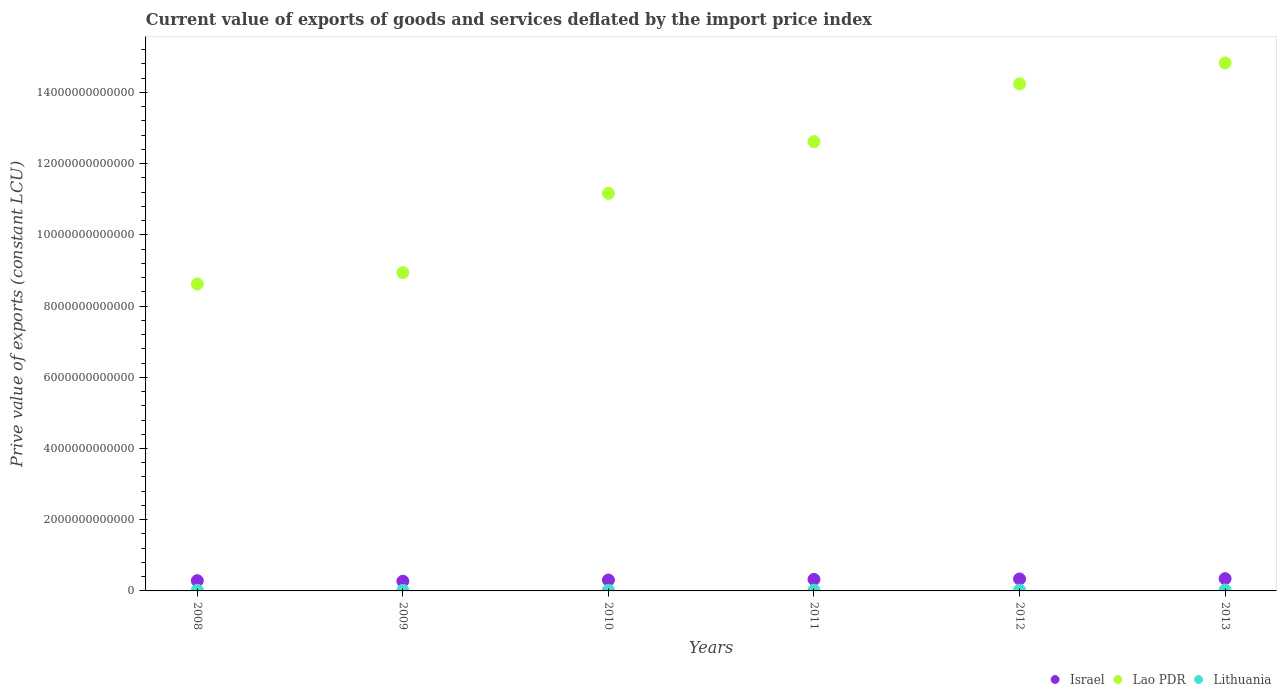How many different coloured dotlines are there?
Give a very brief answer. 3. What is the prive value of exports in Lithuania in 2013?
Provide a succinct answer. 2.54e+1. Across all years, what is the maximum prive value of exports in Israel?
Your answer should be compact. 3.45e+11. Across all years, what is the minimum prive value of exports in Israel?
Offer a very short reply. 2.74e+11. In which year was the prive value of exports in Israel minimum?
Your response must be concise. 2009. What is the total prive value of exports in Lithuania in the graph?
Offer a very short reply. 1.21e+11. What is the difference between the prive value of exports in Lao PDR in 2009 and that in 2012?
Give a very brief answer. -5.30e+12. What is the difference between the prive value of exports in Lithuania in 2011 and the prive value of exports in Lao PDR in 2009?
Ensure brevity in your answer.  -8.92e+12. What is the average prive value of exports in Lithuania per year?
Ensure brevity in your answer.  2.02e+1. In the year 2011, what is the difference between the prive value of exports in Lithuania and prive value of exports in Israel?
Keep it short and to the point. -3.02e+11. In how many years, is the prive value of exports in Lithuania greater than 10400000000000 LCU?
Your answer should be compact. 0. What is the ratio of the prive value of exports in Israel in 2008 to that in 2009?
Ensure brevity in your answer.  1.05. What is the difference between the highest and the second highest prive value of exports in Israel?
Your answer should be very brief. 8.65e+09. What is the difference between the highest and the lowest prive value of exports in Israel?
Keep it short and to the point. 7.11e+1. What is the difference between two consecutive major ticks on the Y-axis?
Offer a terse response. 2.00e+12. Are the values on the major ticks of Y-axis written in scientific E-notation?
Keep it short and to the point. No. Does the graph contain grids?
Ensure brevity in your answer.  No. How many legend labels are there?
Your response must be concise. 3. What is the title of the graph?
Offer a very short reply. Current value of exports of goods and services deflated by the import price index. Does "Guam" appear as one of the legend labels in the graph?
Make the answer very short. No. What is the label or title of the Y-axis?
Make the answer very short. Prive value of exports (constant LCU). What is the Prive value of exports (constant LCU) in Israel in 2008?
Give a very brief answer. 2.88e+11. What is the Prive value of exports (constant LCU) of Lao PDR in 2008?
Provide a short and direct response. 8.62e+12. What is the Prive value of exports (constant LCU) of Lithuania in 2008?
Keep it short and to the point. 1.83e+1. What is the Prive value of exports (constant LCU) in Israel in 2009?
Your answer should be very brief. 2.74e+11. What is the Prive value of exports (constant LCU) of Lao PDR in 2009?
Provide a short and direct response. 8.94e+12. What is the Prive value of exports (constant LCU) of Lithuania in 2009?
Offer a very short reply. 1.54e+1. What is the Prive value of exports (constant LCU) in Israel in 2010?
Your answer should be very brief. 3.07e+11. What is the Prive value of exports (constant LCU) in Lao PDR in 2010?
Your answer should be very brief. 1.12e+13. What is the Prive value of exports (constant LCU) in Lithuania in 2010?
Offer a very short reply. 1.83e+1. What is the Prive value of exports (constant LCU) in Israel in 2011?
Ensure brevity in your answer.  3.23e+11. What is the Prive value of exports (constant LCU) of Lao PDR in 2011?
Provide a short and direct response. 1.26e+13. What is the Prive value of exports (constant LCU) of Lithuania in 2011?
Give a very brief answer. 2.08e+1. What is the Prive value of exports (constant LCU) of Israel in 2012?
Your answer should be very brief. 3.36e+11. What is the Prive value of exports (constant LCU) in Lao PDR in 2012?
Make the answer very short. 1.42e+13. What is the Prive value of exports (constant LCU) in Lithuania in 2012?
Ensure brevity in your answer.  2.32e+1. What is the Prive value of exports (constant LCU) in Israel in 2013?
Your answer should be very brief. 3.45e+11. What is the Prive value of exports (constant LCU) of Lao PDR in 2013?
Your response must be concise. 1.48e+13. What is the Prive value of exports (constant LCU) of Lithuania in 2013?
Offer a very short reply. 2.54e+1. Across all years, what is the maximum Prive value of exports (constant LCU) in Israel?
Your response must be concise. 3.45e+11. Across all years, what is the maximum Prive value of exports (constant LCU) in Lao PDR?
Offer a very short reply. 1.48e+13. Across all years, what is the maximum Prive value of exports (constant LCU) of Lithuania?
Offer a terse response. 2.54e+1. Across all years, what is the minimum Prive value of exports (constant LCU) in Israel?
Ensure brevity in your answer.  2.74e+11. Across all years, what is the minimum Prive value of exports (constant LCU) in Lao PDR?
Your answer should be very brief. 8.62e+12. Across all years, what is the minimum Prive value of exports (constant LCU) of Lithuania?
Ensure brevity in your answer.  1.54e+1. What is the total Prive value of exports (constant LCU) of Israel in the graph?
Your answer should be very brief. 1.87e+12. What is the total Prive value of exports (constant LCU) of Lao PDR in the graph?
Give a very brief answer. 7.04e+13. What is the total Prive value of exports (constant LCU) in Lithuania in the graph?
Provide a succinct answer. 1.21e+11. What is the difference between the Prive value of exports (constant LCU) of Israel in 2008 and that in 2009?
Provide a short and direct response. 1.40e+1. What is the difference between the Prive value of exports (constant LCU) of Lao PDR in 2008 and that in 2009?
Make the answer very short. -3.18e+11. What is the difference between the Prive value of exports (constant LCU) of Lithuania in 2008 and that in 2009?
Your answer should be compact. 2.96e+09. What is the difference between the Prive value of exports (constant LCU) of Israel in 2008 and that in 2010?
Make the answer very short. -1.92e+1. What is the difference between the Prive value of exports (constant LCU) in Lao PDR in 2008 and that in 2010?
Offer a terse response. -2.54e+12. What is the difference between the Prive value of exports (constant LCU) in Lithuania in 2008 and that in 2010?
Give a very brief answer. 2.17e+07. What is the difference between the Prive value of exports (constant LCU) in Israel in 2008 and that in 2011?
Provide a succinct answer. -3.54e+1. What is the difference between the Prive value of exports (constant LCU) in Lao PDR in 2008 and that in 2011?
Keep it short and to the point. -4.00e+12. What is the difference between the Prive value of exports (constant LCU) in Lithuania in 2008 and that in 2011?
Offer a terse response. -2.47e+09. What is the difference between the Prive value of exports (constant LCU) in Israel in 2008 and that in 2012?
Offer a very short reply. -4.84e+1. What is the difference between the Prive value of exports (constant LCU) in Lao PDR in 2008 and that in 2012?
Your answer should be compact. -5.62e+12. What is the difference between the Prive value of exports (constant LCU) in Lithuania in 2008 and that in 2012?
Ensure brevity in your answer.  -4.84e+09. What is the difference between the Prive value of exports (constant LCU) of Israel in 2008 and that in 2013?
Keep it short and to the point. -5.71e+1. What is the difference between the Prive value of exports (constant LCU) of Lao PDR in 2008 and that in 2013?
Your response must be concise. -6.21e+12. What is the difference between the Prive value of exports (constant LCU) of Lithuania in 2008 and that in 2013?
Offer a very short reply. -7.11e+09. What is the difference between the Prive value of exports (constant LCU) of Israel in 2009 and that in 2010?
Provide a short and direct response. -3.32e+1. What is the difference between the Prive value of exports (constant LCU) in Lao PDR in 2009 and that in 2010?
Your response must be concise. -2.23e+12. What is the difference between the Prive value of exports (constant LCU) of Lithuania in 2009 and that in 2010?
Offer a very short reply. -2.94e+09. What is the difference between the Prive value of exports (constant LCU) of Israel in 2009 and that in 2011?
Provide a short and direct response. -4.94e+1. What is the difference between the Prive value of exports (constant LCU) of Lao PDR in 2009 and that in 2011?
Provide a succinct answer. -3.68e+12. What is the difference between the Prive value of exports (constant LCU) of Lithuania in 2009 and that in 2011?
Offer a terse response. -5.42e+09. What is the difference between the Prive value of exports (constant LCU) of Israel in 2009 and that in 2012?
Your answer should be compact. -6.25e+1. What is the difference between the Prive value of exports (constant LCU) in Lao PDR in 2009 and that in 2012?
Your response must be concise. -5.30e+12. What is the difference between the Prive value of exports (constant LCU) of Lithuania in 2009 and that in 2012?
Ensure brevity in your answer.  -7.79e+09. What is the difference between the Prive value of exports (constant LCU) of Israel in 2009 and that in 2013?
Keep it short and to the point. -7.11e+1. What is the difference between the Prive value of exports (constant LCU) of Lao PDR in 2009 and that in 2013?
Offer a very short reply. -5.89e+12. What is the difference between the Prive value of exports (constant LCU) in Lithuania in 2009 and that in 2013?
Provide a short and direct response. -1.01e+1. What is the difference between the Prive value of exports (constant LCU) in Israel in 2010 and that in 2011?
Provide a succinct answer. -1.62e+1. What is the difference between the Prive value of exports (constant LCU) of Lao PDR in 2010 and that in 2011?
Keep it short and to the point. -1.45e+12. What is the difference between the Prive value of exports (constant LCU) of Lithuania in 2010 and that in 2011?
Provide a succinct answer. -2.49e+09. What is the difference between the Prive value of exports (constant LCU) in Israel in 2010 and that in 2012?
Keep it short and to the point. -2.93e+1. What is the difference between the Prive value of exports (constant LCU) in Lao PDR in 2010 and that in 2012?
Your answer should be compact. -3.08e+12. What is the difference between the Prive value of exports (constant LCU) of Lithuania in 2010 and that in 2012?
Give a very brief answer. -4.86e+09. What is the difference between the Prive value of exports (constant LCU) in Israel in 2010 and that in 2013?
Your answer should be very brief. -3.79e+1. What is the difference between the Prive value of exports (constant LCU) in Lao PDR in 2010 and that in 2013?
Provide a succinct answer. -3.66e+12. What is the difference between the Prive value of exports (constant LCU) in Lithuania in 2010 and that in 2013?
Offer a terse response. -7.13e+09. What is the difference between the Prive value of exports (constant LCU) of Israel in 2011 and that in 2012?
Ensure brevity in your answer.  -1.30e+1. What is the difference between the Prive value of exports (constant LCU) in Lao PDR in 2011 and that in 2012?
Make the answer very short. -1.62e+12. What is the difference between the Prive value of exports (constant LCU) of Lithuania in 2011 and that in 2012?
Keep it short and to the point. -2.37e+09. What is the difference between the Prive value of exports (constant LCU) of Israel in 2011 and that in 2013?
Give a very brief answer. -2.17e+1. What is the difference between the Prive value of exports (constant LCU) in Lao PDR in 2011 and that in 2013?
Offer a terse response. -2.21e+12. What is the difference between the Prive value of exports (constant LCU) in Lithuania in 2011 and that in 2013?
Your response must be concise. -4.64e+09. What is the difference between the Prive value of exports (constant LCU) of Israel in 2012 and that in 2013?
Provide a short and direct response. -8.65e+09. What is the difference between the Prive value of exports (constant LCU) in Lao PDR in 2012 and that in 2013?
Provide a short and direct response. -5.88e+11. What is the difference between the Prive value of exports (constant LCU) of Lithuania in 2012 and that in 2013?
Your answer should be very brief. -2.27e+09. What is the difference between the Prive value of exports (constant LCU) of Israel in 2008 and the Prive value of exports (constant LCU) of Lao PDR in 2009?
Ensure brevity in your answer.  -8.65e+12. What is the difference between the Prive value of exports (constant LCU) in Israel in 2008 and the Prive value of exports (constant LCU) in Lithuania in 2009?
Your response must be concise. 2.72e+11. What is the difference between the Prive value of exports (constant LCU) in Lao PDR in 2008 and the Prive value of exports (constant LCU) in Lithuania in 2009?
Offer a very short reply. 8.60e+12. What is the difference between the Prive value of exports (constant LCU) in Israel in 2008 and the Prive value of exports (constant LCU) in Lao PDR in 2010?
Give a very brief answer. -1.09e+13. What is the difference between the Prive value of exports (constant LCU) in Israel in 2008 and the Prive value of exports (constant LCU) in Lithuania in 2010?
Your response must be concise. 2.69e+11. What is the difference between the Prive value of exports (constant LCU) in Lao PDR in 2008 and the Prive value of exports (constant LCU) in Lithuania in 2010?
Your answer should be very brief. 8.60e+12. What is the difference between the Prive value of exports (constant LCU) of Israel in 2008 and the Prive value of exports (constant LCU) of Lao PDR in 2011?
Offer a very short reply. -1.23e+13. What is the difference between the Prive value of exports (constant LCU) of Israel in 2008 and the Prive value of exports (constant LCU) of Lithuania in 2011?
Your answer should be compact. 2.67e+11. What is the difference between the Prive value of exports (constant LCU) in Lao PDR in 2008 and the Prive value of exports (constant LCU) in Lithuania in 2011?
Offer a very short reply. 8.60e+12. What is the difference between the Prive value of exports (constant LCU) in Israel in 2008 and the Prive value of exports (constant LCU) in Lao PDR in 2012?
Provide a succinct answer. -1.40e+13. What is the difference between the Prive value of exports (constant LCU) in Israel in 2008 and the Prive value of exports (constant LCU) in Lithuania in 2012?
Make the answer very short. 2.64e+11. What is the difference between the Prive value of exports (constant LCU) in Lao PDR in 2008 and the Prive value of exports (constant LCU) in Lithuania in 2012?
Give a very brief answer. 8.60e+12. What is the difference between the Prive value of exports (constant LCU) in Israel in 2008 and the Prive value of exports (constant LCU) in Lao PDR in 2013?
Your answer should be compact. -1.45e+13. What is the difference between the Prive value of exports (constant LCU) in Israel in 2008 and the Prive value of exports (constant LCU) in Lithuania in 2013?
Make the answer very short. 2.62e+11. What is the difference between the Prive value of exports (constant LCU) of Lao PDR in 2008 and the Prive value of exports (constant LCU) of Lithuania in 2013?
Your answer should be compact. 8.59e+12. What is the difference between the Prive value of exports (constant LCU) in Israel in 2009 and the Prive value of exports (constant LCU) in Lao PDR in 2010?
Keep it short and to the point. -1.09e+13. What is the difference between the Prive value of exports (constant LCU) in Israel in 2009 and the Prive value of exports (constant LCU) in Lithuania in 2010?
Provide a short and direct response. 2.55e+11. What is the difference between the Prive value of exports (constant LCU) in Lao PDR in 2009 and the Prive value of exports (constant LCU) in Lithuania in 2010?
Provide a succinct answer. 8.92e+12. What is the difference between the Prive value of exports (constant LCU) in Israel in 2009 and the Prive value of exports (constant LCU) in Lao PDR in 2011?
Your answer should be very brief. -1.23e+13. What is the difference between the Prive value of exports (constant LCU) in Israel in 2009 and the Prive value of exports (constant LCU) in Lithuania in 2011?
Your answer should be compact. 2.53e+11. What is the difference between the Prive value of exports (constant LCU) in Lao PDR in 2009 and the Prive value of exports (constant LCU) in Lithuania in 2011?
Keep it short and to the point. 8.92e+12. What is the difference between the Prive value of exports (constant LCU) of Israel in 2009 and the Prive value of exports (constant LCU) of Lao PDR in 2012?
Offer a terse response. -1.40e+13. What is the difference between the Prive value of exports (constant LCU) of Israel in 2009 and the Prive value of exports (constant LCU) of Lithuania in 2012?
Provide a succinct answer. 2.50e+11. What is the difference between the Prive value of exports (constant LCU) in Lao PDR in 2009 and the Prive value of exports (constant LCU) in Lithuania in 2012?
Offer a very short reply. 8.91e+12. What is the difference between the Prive value of exports (constant LCU) in Israel in 2009 and the Prive value of exports (constant LCU) in Lao PDR in 2013?
Provide a short and direct response. -1.46e+13. What is the difference between the Prive value of exports (constant LCU) of Israel in 2009 and the Prive value of exports (constant LCU) of Lithuania in 2013?
Offer a terse response. 2.48e+11. What is the difference between the Prive value of exports (constant LCU) of Lao PDR in 2009 and the Prive value of exports (constant LCU) of Lithuania in 2013?
Your answer should be very brief. 8.91e+12. What is the difference between the Prive value of exports (constant LCU) of Israel in 2010 and the Prive value of exports (constant LCU) of Lao PDR in 2011?
Provide a short and direct response. -1.23e+13. What is the difference between the Prive value of exports (constant LCU) of Israel in 2010 and the Prive value of exports (constant LCU) of Lithuania in 2011?
Your response must be concise. 2.86e+11. What is the difference between the Prive value of exports (constant LCU) of Lao PDR in 2010 and the Prive value of exports (constant LCU) of Lithuania in 2011?
Provide a succinct answer. 1.11e+13. What is the difference between the Prive value of exports (constant LCU) of Israel in 2010 and the Prive value of exports (constant LCU) of Lao PDR in 2012?
Your answer should be compact. -1.39e+13. What is the difference between the Prive value of exports (constant LCU) of Israel in 2010 and the Prive value of exports (constant LCU) of Lithuania in 2012?
Offer a terse response. 2.84e+11. What is the difference between the Prive value of exports (constant LCU) in Lao PDR in 2010 and the Prive value of exports (constant LCU) in Lithuania in 2012?
Make the answer very short. 1.11e+13. What is the difference between the Prive value of exports (constant LCU) in Israel in 2010 and the Prive value of exports (constant LCU) in Lao PDR in 2013?
Offer a very short reply. -1.45e+13. What is the difference between the Prive value of exports (constant LCU) in Israel in 2010 and the Prive value of exports (constant LCU) in Lithuania in 2013?
Make the answer very short. 2.81e+11. What is the difference between the Prive value of exports (constant LCU) in Lao PDR in 2010 and the Prive value of exports (constant LCU) in Lithuania in 2013?
Your response must be concise. 1.11e+13. What is the difference between the Prive value of exports (constant LCU) of Israel in 2011 and the Prive value of exports (constant LCU) of Lao PDR in 2012?
Provide a succinct answer. -1.39e+13. What is the difference between the Prive value of exports (constant LCU) in Israel in 2011 and the Prive value of exports (constant LCU) in Lithuania in 2012?
Give a very brief answer. 3.00e+11. What is the difference between the Prive value of exports (constant LCU) of Lao PDR in 2011 and the Prive value of exports (constant LCU) of Lithuania in 2012?
Provide a succinct answer. 1.26e+13. What is the difference between the Prive value of exports (constant LCU) of Israel in 2011 and the Prive value of exports (constant LCU) of Lao PDR in 2013?
Offer a terse response. -1.45e+13. What is the difference between the Prive value of exports (constant LCU) in Israel in 2011 and the Prive value of exports (constant LCU) in Lithuania in 2013?
Your answer should be very brief. 2.98e+11. What is the difference between the Prive value of exports (constant LCU) in Lao PDR in 2011 and the Prive value of exports (constant LCU) in Lithuania in 2013?
Your answer should be compact. 1.26e+13. What is the difference between the Prive value of exports (constant LCU) in Israel in 2012 and the Prive value of exports (constant LCU) in Lao PDR in 2013?
Provide a succinct answer. -1.45e+13. What is the difference between the Prive value of exports (constant LCU) of Israel in 2012 and the Prive value of exports (constant LCU) of Lithuania in 2013?
Ensure brevity in your answer.  3.11e+11. What is the difference between the Prive value of exports (constant LCU) of Lao PDR in 2012 and the Prive value of exports (constant LCU) of Lithuania in 2013?
Give a very brief answer. 1.42e+13. What is the average Prive value of exports (constant LCU) of Israel per year?
Provide a short and direct response. 3.12e+11. What is the average Prive value of exports (constant LCU) in Lao PDR per year?
Make the answer very short. 1.17e+13. What is the average Prive value of exports (constant LCU) of Lithuania per year?
Provide a short and direct response. 2.02e+1. In the year 2008, what is the difference between the Prive value of exports (constant LCU) in Israel and Prive value of exports (constant LCU) in Lao PDR?
Your response must be concise. -8.33e+12. In the year 2008, what is the difference between the Prive value of exports (constant LCU) of Israel and Prive value of exports (constant LCU) of Lithuania?
Make the answer very short. 2.69e+11. In the year 2008, what is the difference between the Prive value of exports (constant LCU) in Lao PDR and Prive value of exports (constant LCU) in Lithuania?
Keep it short and to the point. 8.60e+12. In the year 2009, what is the difference between the Prive value of exports (constant LCU) of Israel and Prive value of exports (constant LCU) of Lao PDR?
Offer a terse response. -8.66e+12. In the year 2009, what is the difference between the Prive value of exports (constant LCU) in Israel and Prive value of exports (constant LCU) in Lithuania?
Offer a very short reply. 2.58e+11. In the year 2009, what is the difference between the Prive value of exports (constant LCU) of Lao PDR and Prive value of exports (constant LCU) of Lithuania?
Give a very brief answer. 8.92e+12. In the year 2010, what is the difference between the Prive value of exports (constant LCU) in Israel and Prive value of exports (constant LCU) in Lao PDR?
Provide a succinct answer. -1.09e+13. In the year 2010, what is the difference between the Prive value of exports (constant LCU) of Israel and Prive value of exports (constant LCU) of Lithuania?
Your answer should be very brief. 2.88e+11. In the year 2010, what is the difference between the Prive value of exports (constant LCU) of Lao PDR and Prive value of exports (constant LCU) of Lithuania?
Your response must be concise. 1.11e+13. In the year 2011, what is the difference between the Prive value of exports (constant LCU) of Israel and Prive value of exports (constant LCU) of Lao PDR?
Your answer should be compact. -1.23e+13. In the year 2011, what is the difference between the Prive value of exports (constant LCU) in Israel and Prive value of exports (constant LCU) in Lithuania?
Your answer should be compact. 3.02e+11. In the year 2011, what is the difference between the Prive value of exports (constant LCU) in Lao PDR and Prive value of exports (constant LCU) in Lithuania?
Make the answer very short. 1.26e+13. In the year 2012, what is the difference between the Prive value of exports (constant LCU) in Israel and Prive value of exports (constant LCU) in Lao PDR?
Ensure brevity in your answer.  -1.39e+13. In the year 2012, what is the difference between the Prive value of exports (constant LCU) in Israel and Prive value of exports (constant LCU) in Lithuania?
Make the answer very short. 3.13e+11. In the year 2012, what is the difference between the Prive value of exports (constant LCU) of Lao PDR and Prive value of exports (constant LCU) of Lithuania?
Ensure brevity in your answer.  1.42e+13. In the year 2013, what is the difference between the Prive value of exports (constant LCU) in Israel and Prive value of exports (constant LCU) in Lao PDR?
Offer a terse response. -1.45e+13. In the year 2013, what is the difference between the Prive value of exports (constant LCU) of Israel and Prive value of exports (constant LCU) of Lithuania?
Your answer should be very brief. 3.19e+11. In the year 2013, what is the difference between the Prive value of exports (constant LCU) in Lao PDR and Prive value of exports (constant LCU) in Lithuania?
Your response must be concise. 1.48e+13. What is the ratio of the Prive value of exports (constant LCU) in Israel in 2008 to that in 2009?
Your response must be concise. 1.05. What is the ratio of the Prive value of exports (constant LCU) of Lao PDR in 2008 to that in 2009?
Offer a terse response. 0.96. What is the ratio of the Prive value of exports (constant LCU) in Lithuania in 2008 to that in 2009?
Provide a short and direct response. 1.19. What is the ratio of the Prive value of exports (constant LCU) in Israel in 2008 to that in 2010?
Make the answer very short. 0.94. What is the ratio of the Prive value of exports (constant LCU) in Lao PDR in 2008 to that in 2010?
Provide a short and direct response. 0.77. What is the ratio of the Prive value of exports (constant LCU) in Israel in 2008 to that in 2011?
Your answer should be compact. 0.89. What is the ratio of the Prive value of exports (constant LCU) of Lao PDR in 2008 to that in 2011?
Give a very brief answer. 0.68. What is the ratio of the Prive value of exports (constant LCU) of Lithuania in 2008 to that in 2011?
Provide a succinct answer. 0.88. What is the ratio of the Prive value of exports (constant LCU) in Israel in 2008 to that in 2012?
Give a very brief answer. 0.86. What is the ratio of the Prive value of exports (constant LCU) in Lao PDR in 2008 to that in 2012?
Your response must be concise. 0.61. What is the ratio of the Prive value of exports (constant LCU) in Lithuania in 2008 to that in 2012?
Your answer should be very brief. 0.79. What is the ratio of the Prive value of exports (constant LCU) in Israel in 2008 to that in 2013?
Give a very brief answer. 0.83. What is the ratio of the Prive value of exports (constant LCU) of Lao PDR in 2008 to that in 2013?
Provide a succinct answer. 0.58. What is the ratio of the Prive value of exports (constant LCU) of Lithuania in 2008 to that in 2013?
Offer a terse response. 0.72. What is the ratio of the Prive value of exports (constant LCU) of Israel in 2009 to that in 2010?
Provide a succinct answer. 0.89. What is the ratio of the Prive value of exports (constant LCU) of Lao PDR in 2009 to that in 2010?
Ensure brevity in your answer.  0.8. What is the ratio of the Prive value of exports (constant LCU) in Lithuania in 2009 to that in 2010?
Offer a terse response. 0.84. What is the ratio of the Prive value of exports (constant LCU) of Israel in 2009 to that in 2011?
Your answer should be compact. 0.85. What is the ratio of the Prive value of exports (constant LCU) of Lao PDR in 2009 to that in 2011?
Your answer should be compact. 0.71. What is the ratio of the Prive value of exports (constant LCU) in Lithuania in 2009 to that in 2011?
Provide a succinct answer. 0.74. What is the ratio of the Prive value of exports (constant LCU) in Israel in 2009 to that in 2012?
Ensure brevity in your answer.  0.81. What is the ratio of the Prive value of exports (constant LCU) of Lao PDR in 2009 to that in 2012?
Keep it short and to the point. 0.63. What is the ratio of the Prive value of exports (constant LCU) of Lithuania in 2009 to that in 2012?
Ensure brevity in your answer.  0.66. What is the ratio of the Prive value of exports (constant LCU) of Israel in 2009 to that in 2013?
Offer a very short reply. 0.79. What is the ratio of the Prive value of exports (constant LCU) in Lao PDR in 2009 to that in 2013?
Offer a very short reply. 0.6. What is the ratio of the Prive value of exports (constant LCU) of Lithuania in 2009 to that in 2013?
Provide a short and direct response. 0.6. What is the ratio of the Prive value of exports (constant LCU) in Israel in 2010 to that in 2011?
Ensure brevity in your answer.  0.95. What is the ratio of the Prive value of exports (constant LCU) in Lao PDR in 2010 to that in 2011?
Give a very brief answer. 0.88. What is the ratio of the Prive value of exports (constant LCU) in Lithuania in 2010 to that in 2011?
Provide a succinct answer. 0.88. What is the ratio of the Prive value of exports (constant LCU) in Israel in 2010 to that in 2012?
Provide a succinct answer. 0.91. What is the ratio of the Prive value of exports (constant LCU) of Lao PDR in 2010 to that in 2012?
Your answer should be compact. 0.78. What is the ratio of the Prive value of exports (constant LCU) in Lithuania in 2010 to that in 2012?
Offer a very short reply. 0.79. What is the ratio of the Prive value of exports (constant LCU) in Israel in 2010 to that in 2013?
Make the answer very short. 0.89. What is the ratio of the Prive value of exports (constant LCU) in Lao PDR in 2010 to that in 2013?
Offer a very short reply. 0.75. What is the ratio of the Prive value of exports (constant LCU) in Lithuania in 2010 to that in 2013?
Your answer should be very brief. 0.72. What is the ratio of the Prive value of exports (constant LCU) of Israel in 2011 to that in 2012?
Make the answer very short. 0.96. What is the ratio of the Prive value of exports (constant LCU) in Lao PDR in 2011 to that in 2012?
Your response must be concise. 0.89. What is the ratio of the Prive value of exports (constant LCU) in Lithuania in 2011 to that in 2012?
Keep it short and to the point. 0.9. What is the ratio of the Prive value of exports (constant LCU) in Israel in 2011 to that in 2013?
Your answer should be compact. 0.94. What is the ratio of the Prive value of exports (constant LCU) of Lao PDR in 2011 to that in 2013?
Provide a succinct answer. 0.85. What is the ratio of the Prive value of exports (constant LCU) in Lithuania in 2011 to that in 2013?
Keep it short and to the point. 0.82. What is the ratio of the Prive value of exports (constant LCU) in Israel in 2012 to that in 2013?
Offer a terse response. 0.97. What is the ratio of the Prive value of exports (constant LCU) in Lao PDR in 2012 to that in 2013?
Your answer should be compact. 0.96. What is the ratio of the Prive value of exports (constant LCU) of Lithuania in 2012 to that in 2013?
Offer a terse response. 0.91. What is the difference between the highest and the second highest Prive value of exports (constant LCU) in Israel?
Provide a succinct answer. 8.65e+09. What is the difference between the highest and the second highest Prive value of exports (constant LCU) of Lao PDR?
Offer a very short reply. 5.88e+11. What is the difference between the highest and the second highest Prive value of exports (constant LCU) in Lithuania?
Your response must be concise. 2.27e+09. What is the difference between the highest and the lowest Prive value of exports (constant LCU) in Israel?
Ensure brevity in your answer.  7.11e+1. What is the difference between the highest and the lowest Prive value of exports (constant LCU) in Lao PDR?
Your answer should be compact. 6.21e+12. What is the difference between the highest and the lowest Prive value of exports (constant LCU) of Lithuania?
Ensure brevity in your answer.  1.01e+1. 